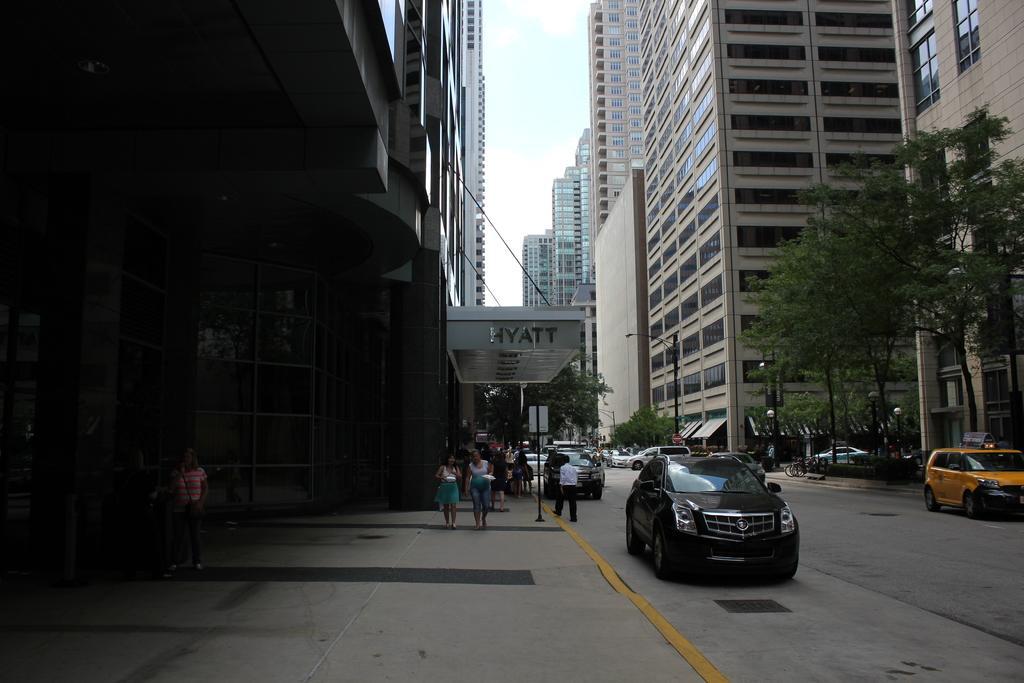Could you give a brief overview of what you see in this image? This is an outside view. Here I can see few cars and people on the ground. On the left side few people are walking on the footpath. On the right side there are few trees. In the background there are buildings. At the top of the image I can see the sky. 